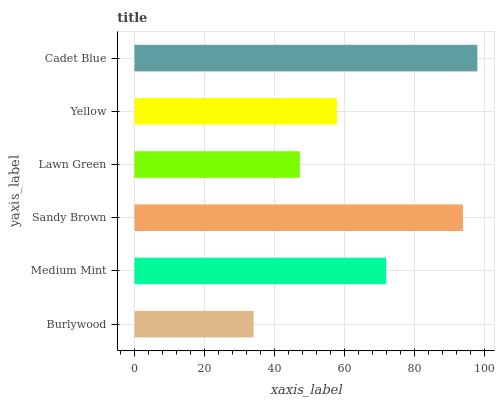Is Burlywood the minimum?
Answer yes or no. Yes. Is Cadet Blue the maximum?
Answer yes or no. Yes. Is Medium Mint the minimum?
Answer yes or no. No. Is Medium Mint the maximum?
Answer yes or no. No. Is Medium Mint greater than Burlywood?
Answer yes or no. Yes. Is Burlywood less than Medium Mint?
Answer yes or no. Yes. Is Burlywood greater than Medium Mint?
Answer yes or no. No. Is Medium Mint less than Burlywood?
Answer yes or no. No. Is Medium Mint the high median?
Answer yes or no. Yes. Is Yellow the low median?
Answer yes or no. Yes. Is Yellow the high median?
Answer yes or no. No. Is Lawn Green the low median?
Answer yes or no. No. 